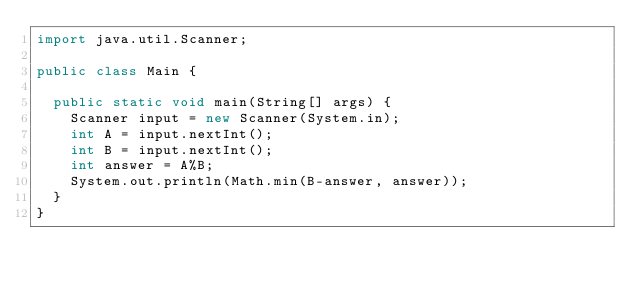<code> <loc_0><loc_0><loc_500><loc_500><_Java_>import java.util.Scanner;

public class Main {

	public static void main(String[] args) {
		Scanner input = new Scanner(System.in);
		int A = input.nextInt();
		int B = input.nextInt();
		int answer = A%B;
		System.out.println(Math.min(B-answer, answer));
	}
}</code> 